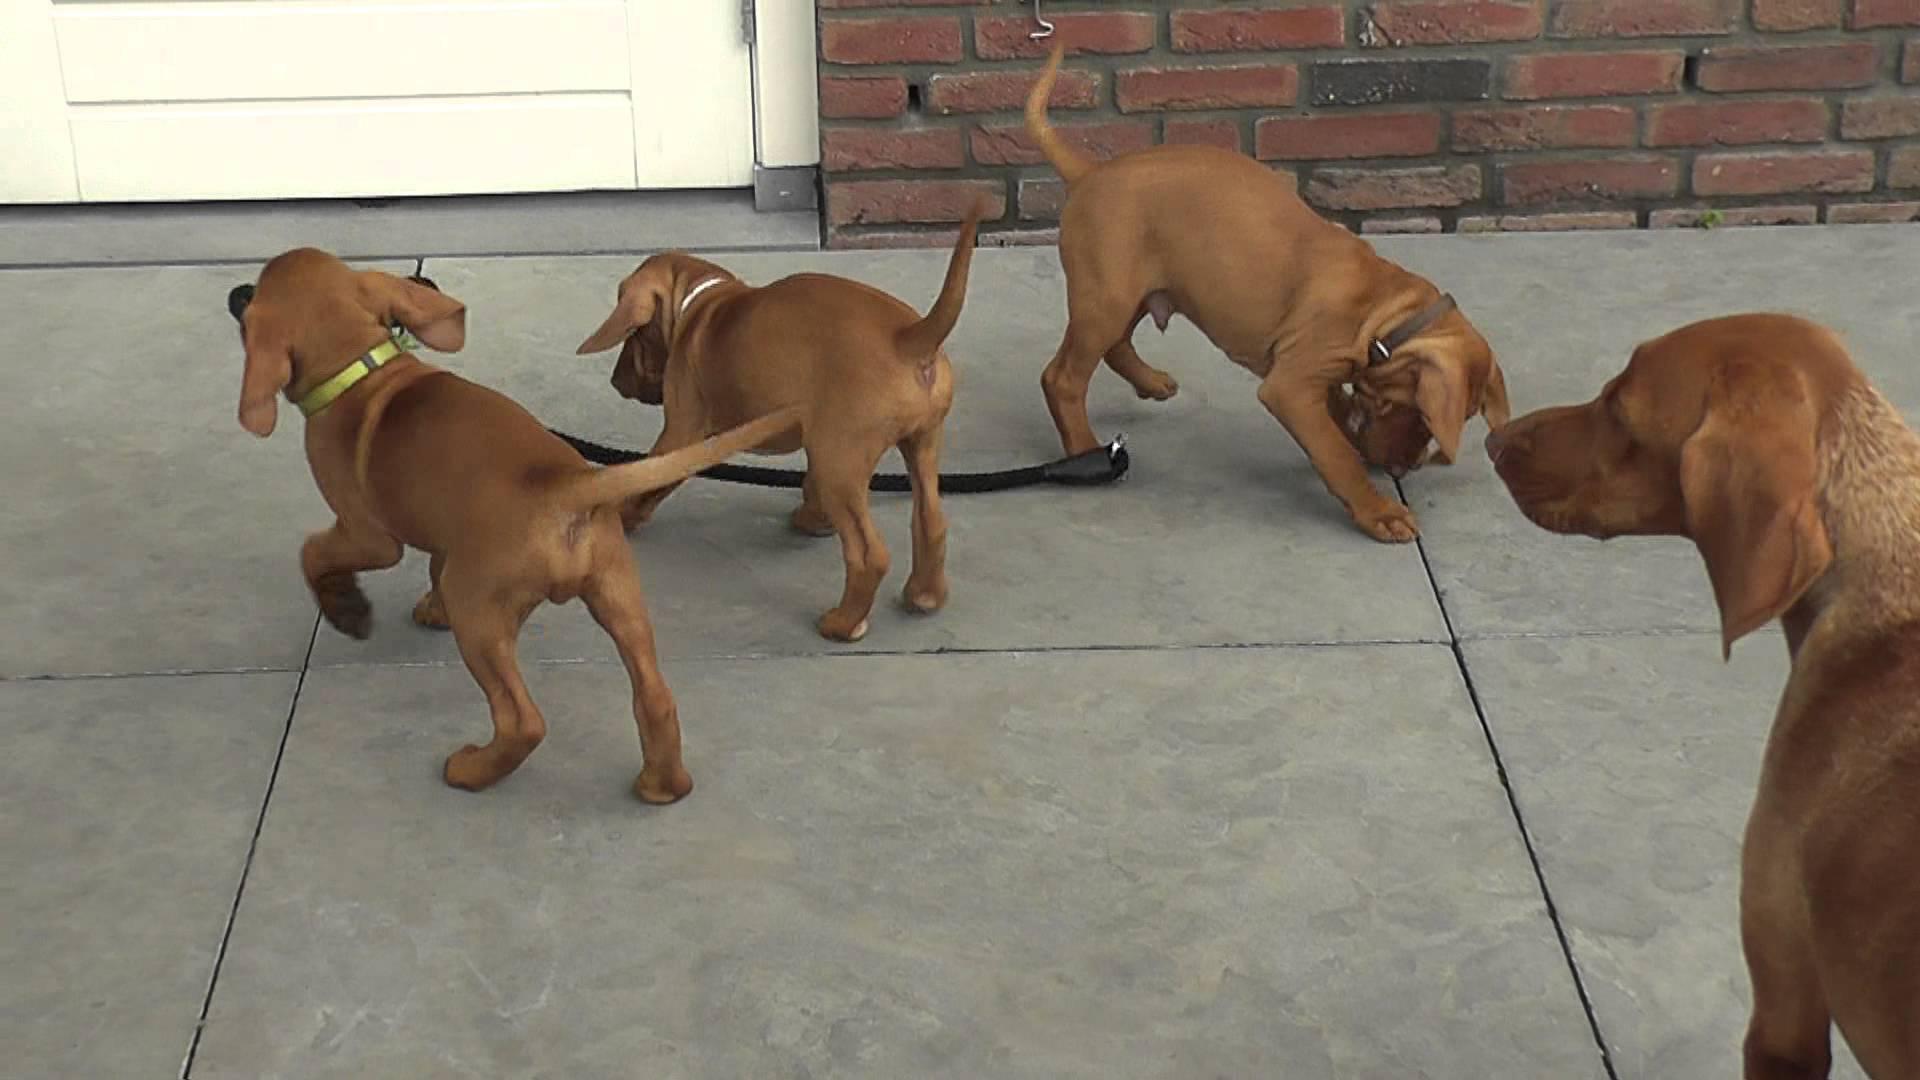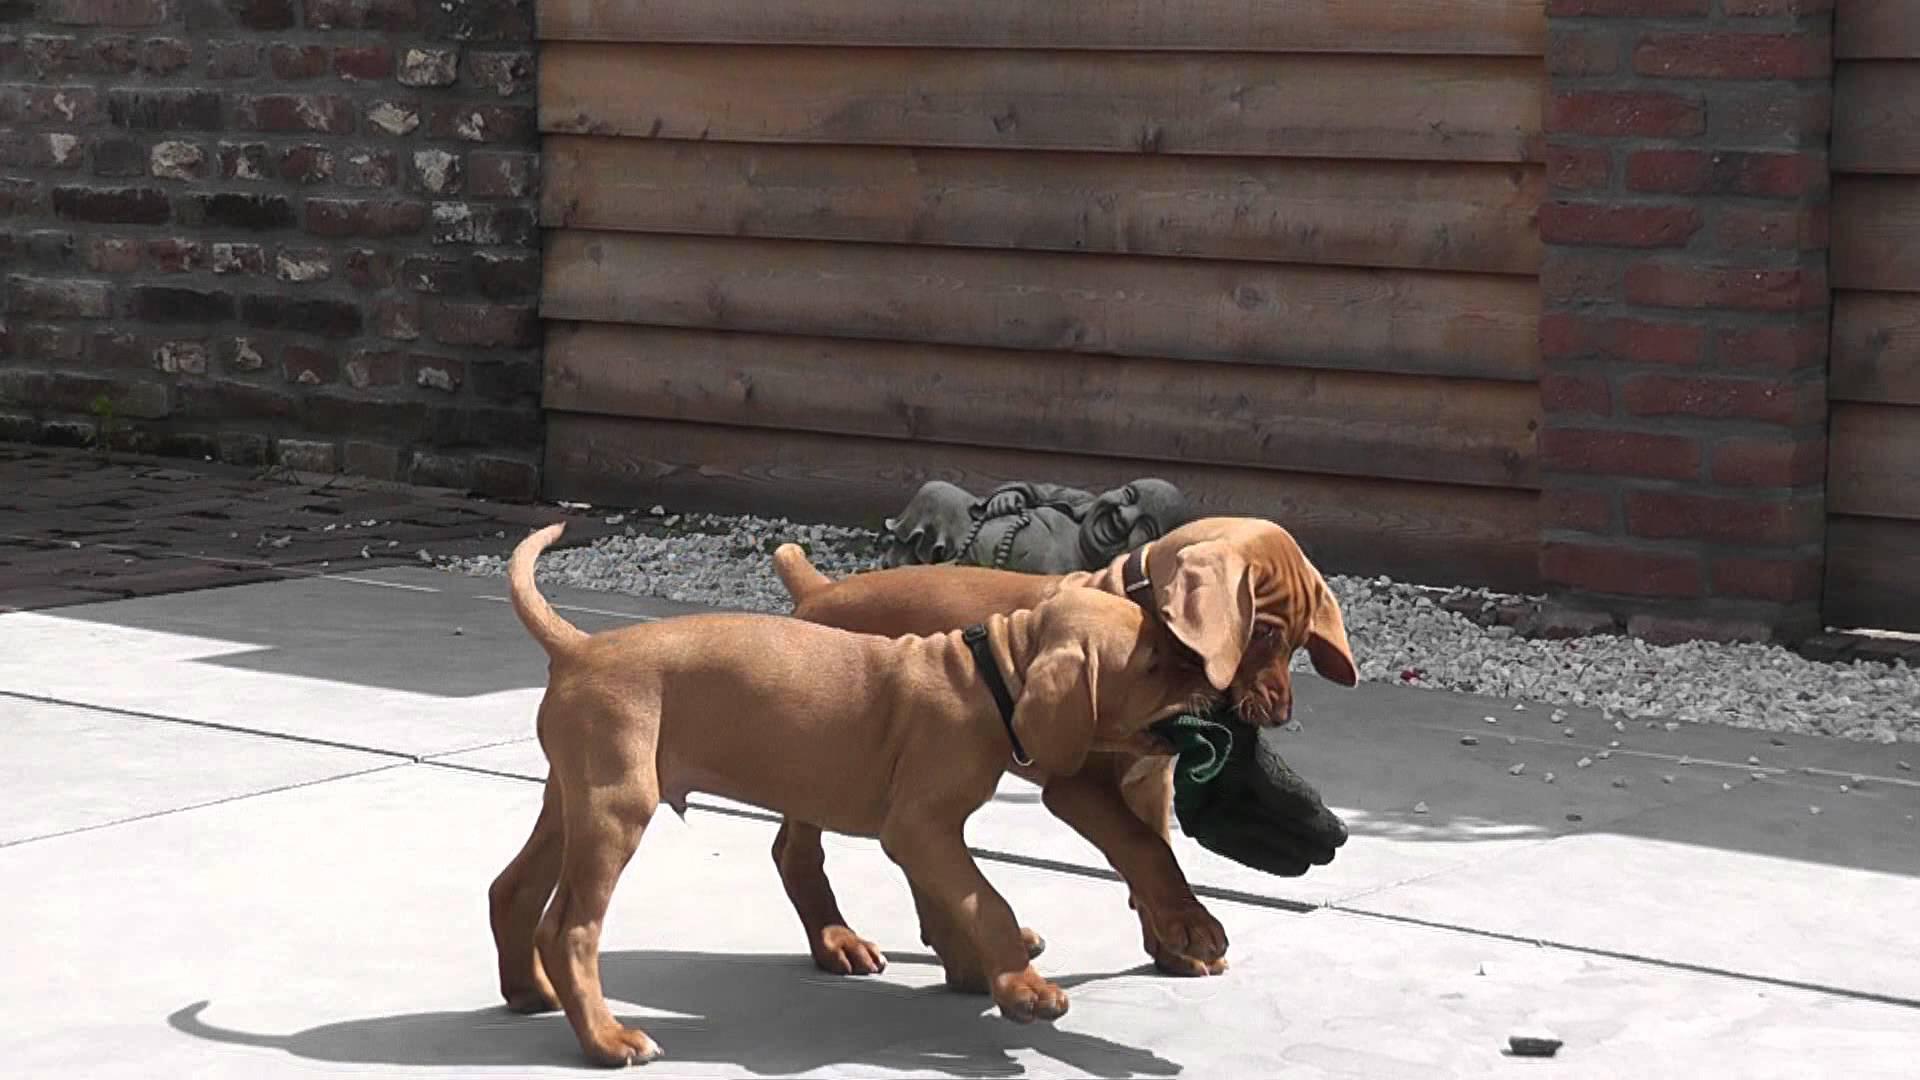The first image is the image on the left, the second image is the image on the right. Assess this claim about the two images: "In at least one image there is a single puppy whose face is tilted left.". Correct or not? Answer yes or no. No. The first image is the image on the left, the second image is the image on the right. Assess this claim about the two images: "There are at most 5 dogs in total.". Correct or not? Answer yes or no. No. 